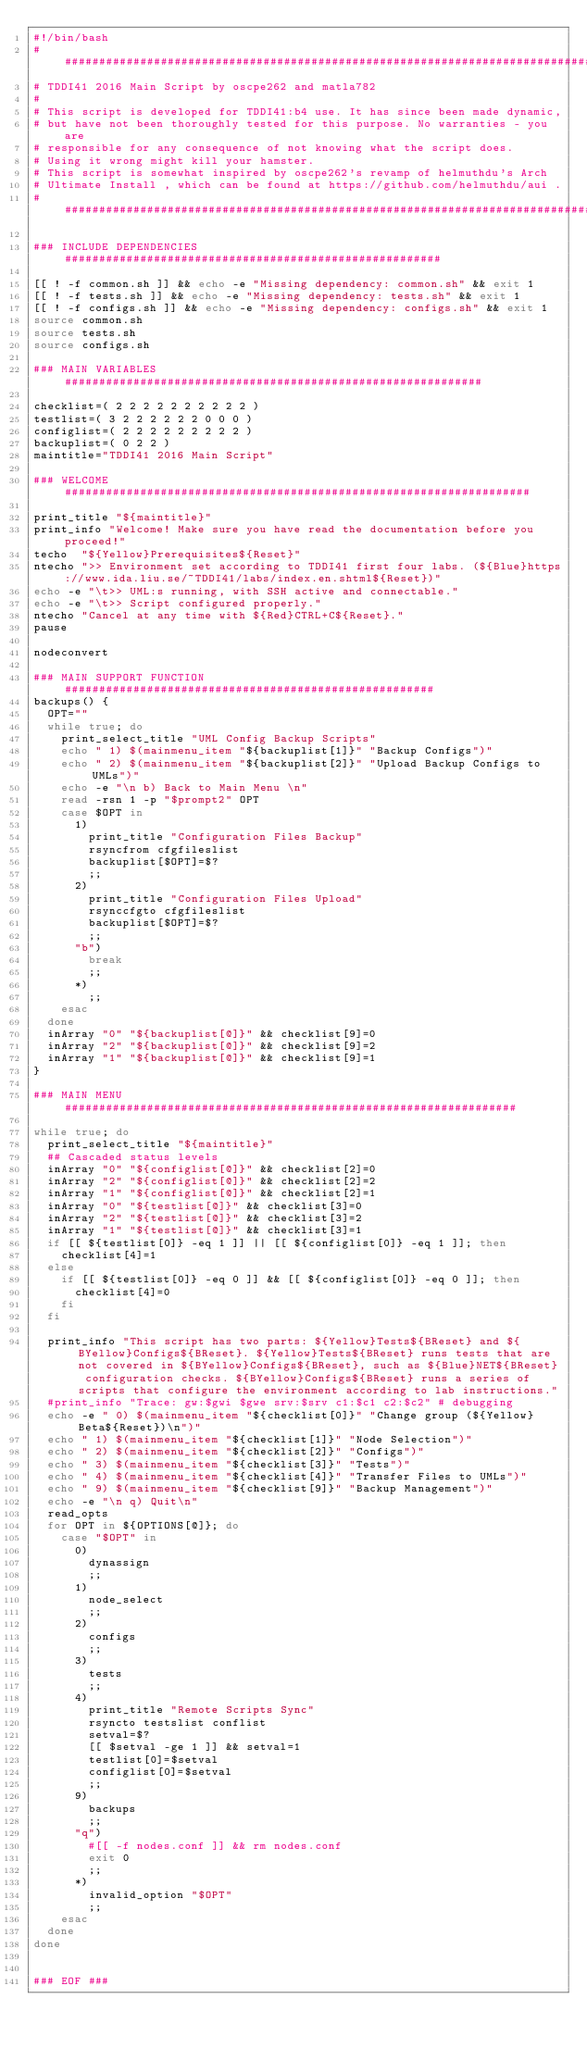Convert code to text. <code><loc_0><loc_0><loc_500><loc_500><_Bash_>#!/bin/bash
################################################################################
# TDDI41 2016 Main Script by oscpe262 and matla782
#
# This script is developed for TDDI41:b4 use. It has since been made dynamic,
# but have not been thoroughly tested for this purpose. No warranties - you are
# responsible for any consequence of not knowing what the script does.
# Using it wrong might kill your hamster.
# This script is somewhat inspired by oscpe262's revamp of helmuthdu's Arch
# Ultimate Install , which can be found at https://github.com/helmuthdu/aui .
################################################################################

### INCLUDE DEPENDENCIES #######################################################

[[ ! -f common.sh ]] && echo -e "Missing dependency: common.sh" && exit 1
[[ ! -f tests.sh ]] && echo -e "Missing dependency: tests.sh" && exit 1
[[ ! -f configs.sh ]] && echo -e "Missing dependency: configs.sh" && exit 1
source common.sh
source tests.sh
source configs.sh

### MAIN VARIABLES #############################################################

checklist=( 2 2 2 2 2 2 2 2 2 2 )
testlist=( 3 2 2 2 2 2 2 0 0 0 )
configlist=( 2 2 2 2 2 2 2 2 2 )
backuplist=( 0 2 2 )
maintitle="TDDI41 2016 Main Script"

### WELCOME ####################################################################

print_title "${maintitle}"
print_info "Welcome! Make sure you have read the documentation before you proceed!"
techo  "${Yellow}Prerequisites${Reset}"
ntecho ">> Environment set according to TDDI41 first four labs. (${Blue}https://www.ida.liu.se/~TDDI41/labs/index.en.shtml${Reset})"
echo -e "\t>> UML:s running, with SSH active and connectable."
echo -e "\t>> Script configured properly."
ntecho "Cancel at any time with ${Red}CTRL+C${Reset}."
pause

nodeconvert

### MAIN SUPPORT FUNCTION ######################################################
backups() {
  OPT=""
  while true; do
    print_select_title "UML Config Backup Scripts"
    echo " 1) $(mainmenu_item "${backuplist[1]}" "Backup Configs")"
    echo " 2) $(mainmenu_item "${backuplist[2]}" "Upload Backup Configs to UMLs")"
    echo -e "\n b) Back to Main Menu \n"
    read -rsn 1 -p "$prompt2" OPT
    case $OPT in
      1)
        print_title "Configuration Files Backup"
        rsyncfrom cfgfileslist
        backuplist[$OPT]=$?
        ;;
      2)
        print_title "Configuration Files Upload"
        rsynccfgto cfgfileslist
        backuplist[$OPT]=$?
        ;;
      "b")
        break
        ;;
      *)
        ;;
    esac
  done
  inArray "0" "${backuplist[@]}" && checklist[9]=0
  inArray "2" "${backuplist[@]}" && checklist[9]=2
  inArray "1" "${backuplist[@]}" && checklist[9]=1
}

### MAIN MENU ##################################################################

while true; do
  print_select_title "${maintitle}"
  ## Cascaded status levels
	inArray "0" "${configlist[@]}" && checklist[2]=0
  inArray "2" "${configlist[@]}" && checklist[2]=2
  inArray "1" "${configlist[@]}" && checklist[2]=1
	inArray "0" "${testlist[@]}" && checklist[3]=0
  inArray "2" "${testlist[@]}" && checklist[3]=2
  inArray "1" "${testlist[@]}" && checklist[3]=1
  if [[ ${testlist[0]} -eq 1 ]] || [[ ${configlist[0]} -eq 1 ]]; then
    checklist[4]=1
  else
    if [[ ${testlist[0]} -eq 0 ]] && [[ ${configlist[0]} -eq 0 ]]; then
      checklist[4]=0
    fi
  fi

  print_info "This script has two parts: ${Yellow}Tests${BReset} and ${BYellow}Configs${BReset}. ${Yellow}Tests${BReset} runs tests that are not covered in ${BYellow}Configs${BReset}, such as ${Blue}NET${BReset} configuration checks. ${BYellow}Configs${BReset} runs a series of scripts that configure the environment according to lab instructions."
  #print_info "Trace: gw:$gwi $gwe srv:$srv c1:$c1 c2:$c2" # debugging
  echo -e " 0) $(mainmenu_item "${checklist[0]}" "Change group (${Yellow}Beta${Reset})\n")"
  echo " 1) $(mainmenu_item "${checklist[1]}" "Node Selection")"
  echo " 2) $(mainmenu_item "${checklist[2]}" "Configs")"
  echo " 3) $(mainmenu_item "${checklist[3]}" "Tests")"
  echo " 4) $(mainmenu_item "${checklist[4]}" "Transfer Files to UMLs")"
  echo " 9) $(mainmenu_item "${checklist[9]}" "Backup Management")"
  echo -e "\n q) Quit\n"
  read_opts
  for OPT in ${OPTIONS[@]}; do
    case "$OPT" in
      0)
        dynassign
        ;;
      1)
        node_select
        ;;
      2)
        configs
        ;;
      3)
        tests
        ;;
      4)
        print_title "Remote Scripts Sync"
        rsyncto testslist conflist
        setval=$?
        [[ $setval -ge 1 ]] && setval=1
        testlist[0]=$setval
			  configlist[0]=$setval
        ;;
      9)
        backups
        ;;
      "q")
        #[[ -f nodes.conf ]] && rm nodes.conf
        exit 0
        ;;
      *)
        invalid_option "$OPT"
        ;;
    esac
  done
done


### EOF ###
</code> 